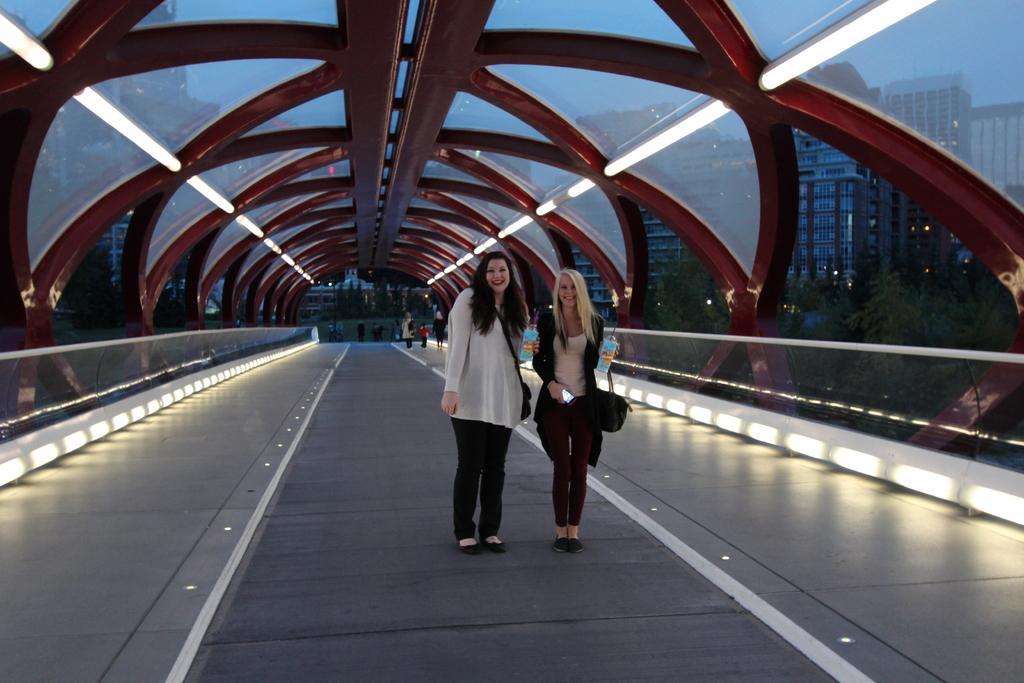Can you describe this image briefly? In this image there are two persons standing on the bridge, and in the background there are group of people, trees, buildings,sky. 